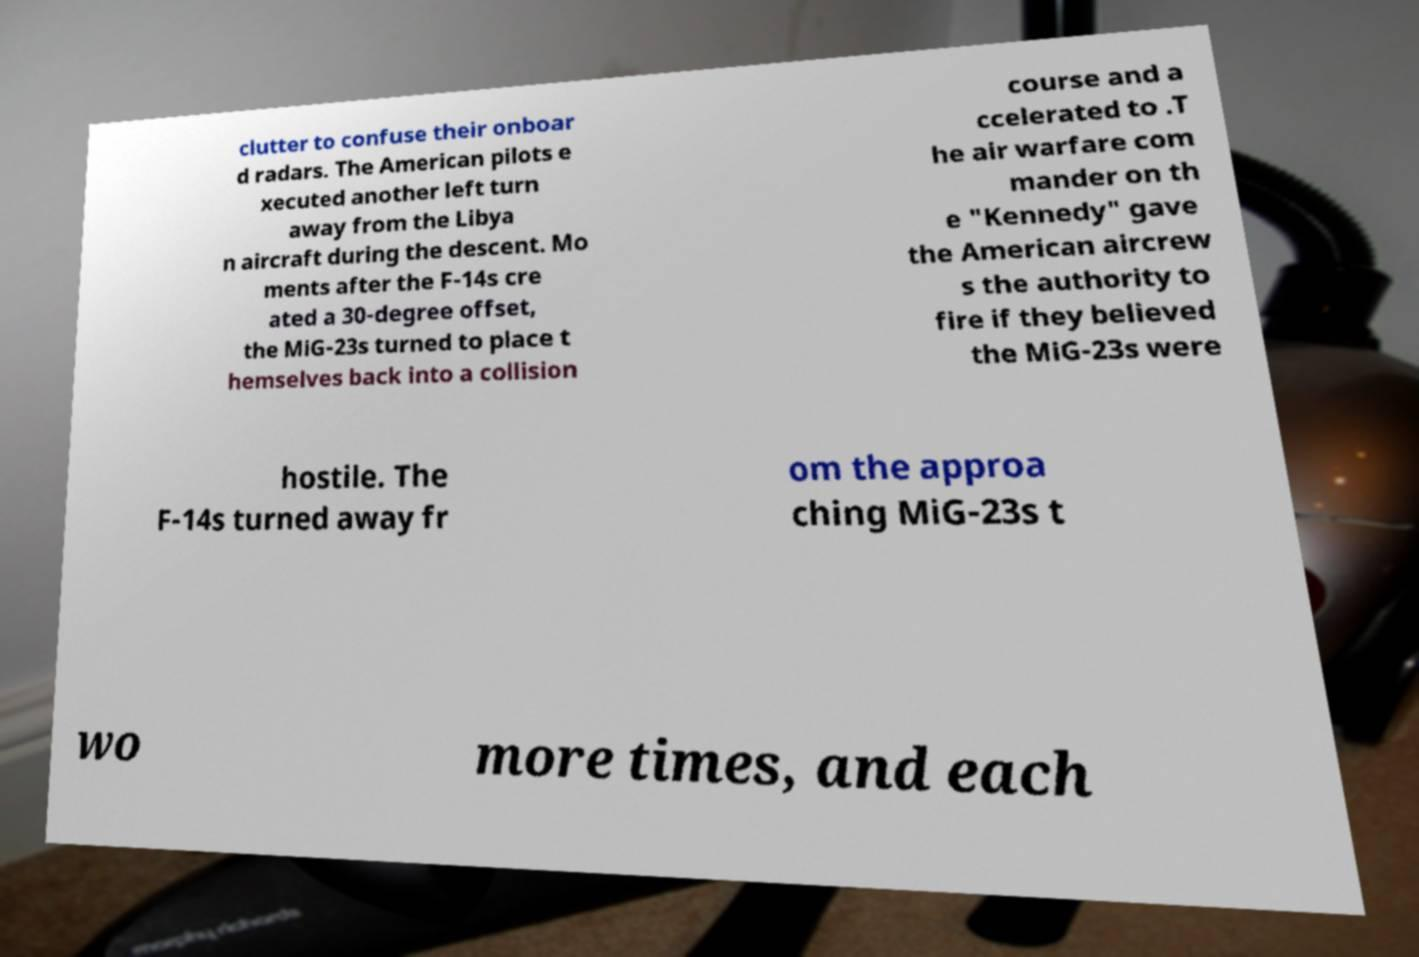Can you read and provide the text displayed in the image?This photo seems to have some interesting text. Can you extract and type it out for me? clutter to confuse their onboar d radars. The American pilots e xecuted another left turn away from the Libya n aircraft during the descent. Mo ments after the F-14s cre ated a 30-degree offset, the MiG-23s turned to place t hemselves back into a collision course and a ccelerated to .T he air warfare com mander on th e "Kennedy" gave the American aircrew s the authority to fire if they believed the MiG-23s were hostile. The F-14s turned away fr om the approa ching MiG-23s t wo more times, and each 